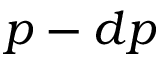Convert formula to latex. <formula><loc_0><loc_0><loc_500><loc_500>p - d p</formula> 